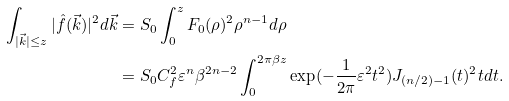<formula> <loc_0><loc_0><loc_500><loc_500>\int _ { | \vec { k } | \leq z } | \hat { f } ( \vec { k } ) | ^ { 2 } d \vec { k } & = S _ { 0 } \int _ { 0 } ^ { z } F _ { 0 } ( \rho ) ^ { 2 } \rho ^ { n - 1 } d \rho \\ & = S _ { 0 } C _ { f } ^ { 2 } \varepsilon ^ { n } \beta ^ { 2 n - 2 } \int _ { 0 } ^ { 2 \pi \beta z } \exp ( - \frac { 1 } { 2 \pi } \varepsilon ^ { 2 } t ^ { 2 } ) J _ { ( n / 2 ) - 1 } ( t ) ^ { 2 } t d t .</formula> 